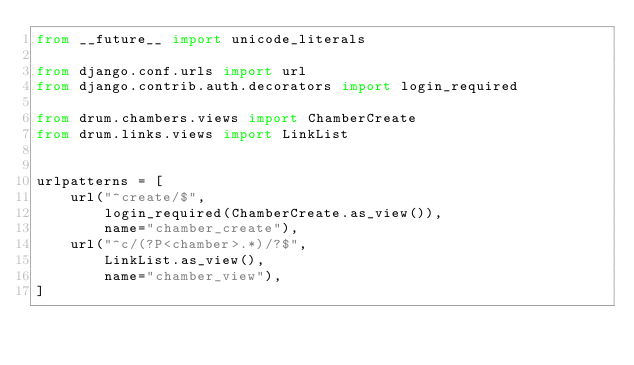Convert code to text. <code><loc_0><loc_0><loc_500><loc_500><_Python_>from __future__ import unicode_literals

from django.conf.urls import url
from django.contrib.auth.decorators import login_required

from drum.chambers.views import ChamberCreate
from drum.links.views import LinkList


urlpatterns = [
    url("^create/$",
        login_required(ChamberCreate.as_view()),
        name="chamber_create"),
    url("^c/(?P<chamber>.*)/?$",
        LinkList.as_view(),
        name="chamber_view"),
]
</code> 